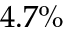<formula> <loc_0><loc_0><loc_500><loc_500>4 . 7 \%</formula> 